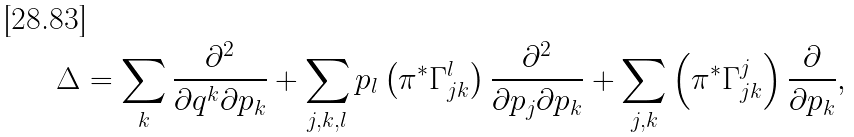<formula> <loc_0><loc_0><loc_500><loc_500>\Delta = \sum _ { k } \frac { \partial ^ { 2 } } { \partial q ^ { k } \partial p _ { k } } + \sum _ { j , k , l } p _ { l } \left ( \pi ^ { * } \Gamma ^ { l } _ { j k } \right ) \frac { \partial ^ { 2 } } { \partial p _ { j } \partial p _ { k } } + \sum _ { j , k } \left ( \pi ^ { * } \Gamma ^ { j } _ { j k } \right ) \frac { \partial } { \partial p _ { k } } ,</formula> 